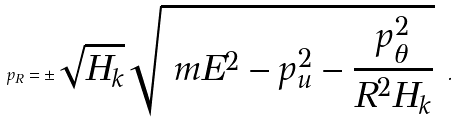<formula> <loc_0><loc_0><loc_500><loc_500>p _ { R } = \pm \sqrt { H _ { k } } \sqrt { \ m E ^ { 2 } - p _ { u } ^ { 2 } - \frac { p ^ { 2 } _ { \theta } } { R ^ { 2 } H _ { k } } } \ .</formula> 